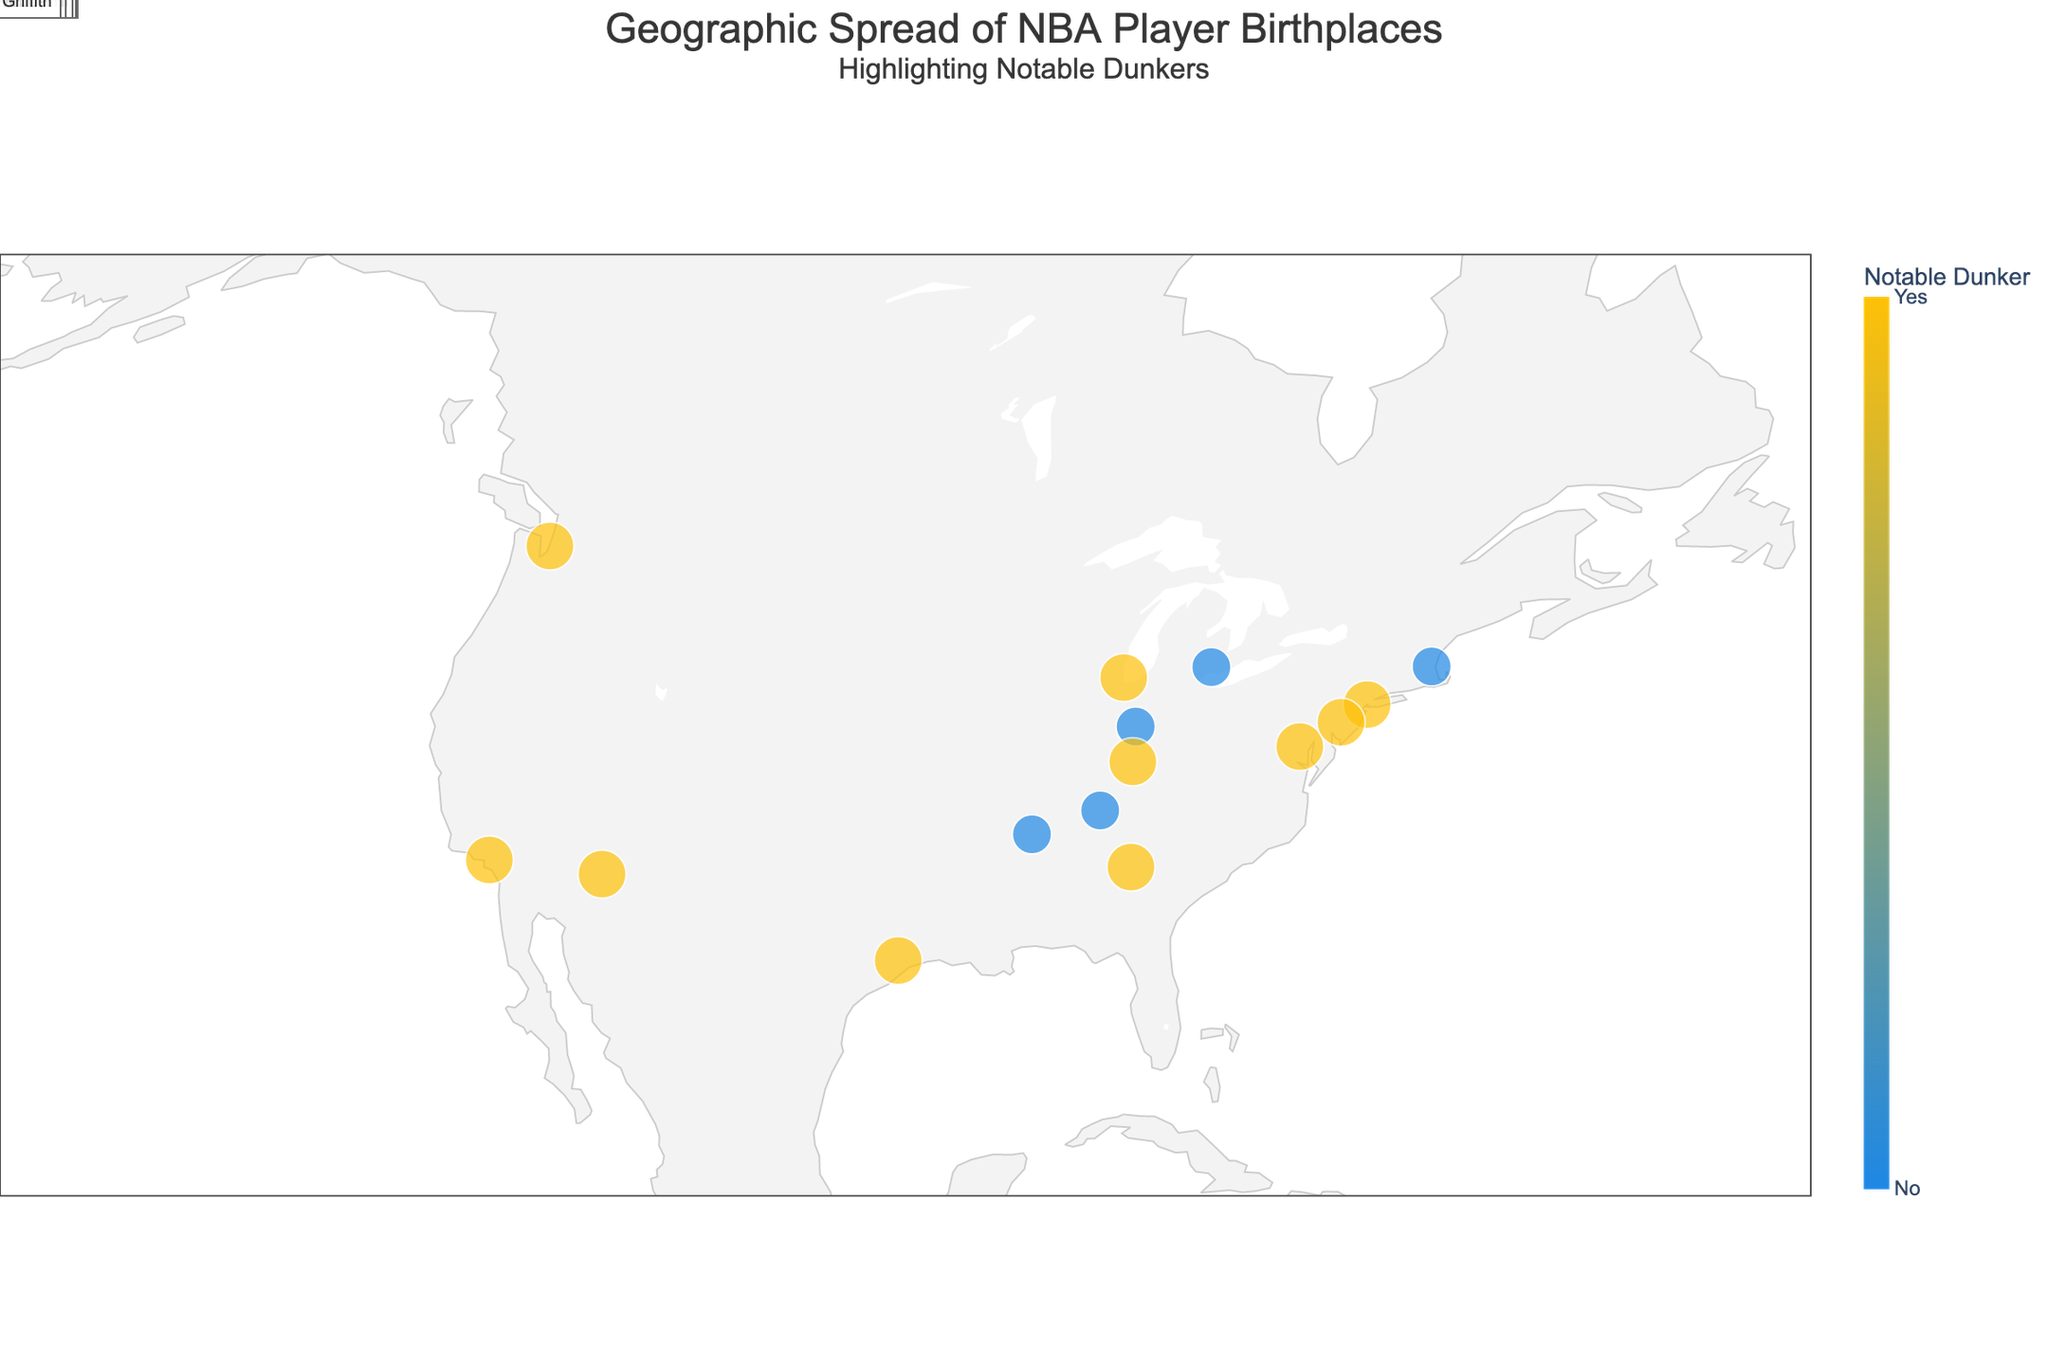Which city has the highest concentration of notable dunkers? To determine this, observe the markers for notable dunkers on the map and see if any city has more than one notable dunker. Brooklyn is the birthplace of Michael Jordan, a notable dunker. Washington, D.C. has Elgin Baylor, another notable dunker. This pattern indicates Brooklyn, New York has multiple notable dunkers.
Answer: Brooklyn, NY How many players from New York are noted as notable dunkers? Look at the data for players and their birthplaces, then count how many notable dunkers (indicated by the color and/or marker size) are from New York. Michael Jordan and Julius Erving are both from New York and are classified as notable dunkers.
Answer: 2 What is the ratio of notable dunkers to non-notable dunkers? Count the number of notable dunkers and non-notable dunkers on the plot. There are 10 notable dunkers and 5 non-notable dunkers, so the ratio is calculated as 10/5.
Answer: 2:1 Which notable dunker was born furthest west in the United States? Identify the notable dunker markers and check the longitudes to find the furthest west position. Jason Richardson, born in Saginaw, MI, with a longitude of -122.3321, is furthest west.
Answer: Jason Richardson Are there any players born in the Midwest noted as notable dunkers? Check the geographic region for the Midwest (generally includes Indiana, Michigan, Ohio, Illinois, Iowa, Kansas, Missouri, Nebraska, and Wisconsin) and see if there are any markers indicating notable dunkers. Jason Richardson (Saginaw, MI) and Darrell Griffith (Louisville, KY) are in the Midwest and are notable dunkers.
Answer: Yes Which player from the dataset was born in the southernmost city? Compare the latitudes of all the players, where the city with the lowest latitude is the southernmost. Vince Carter from Daytona Beach, FL, with a latitude of 29.2108 is the southernmost.
Answer: Vince Carter Are there any players marked as notable dunkers born in the Northwest region of the U.S.? Observe the markers in the Northwest region (encompasses Washington, Oregon, Idaho, and sometimes Wyoming and Montana) to identify if any are notable dunkers. There are no notable dunkers from the Northwest region.
Answer: No 